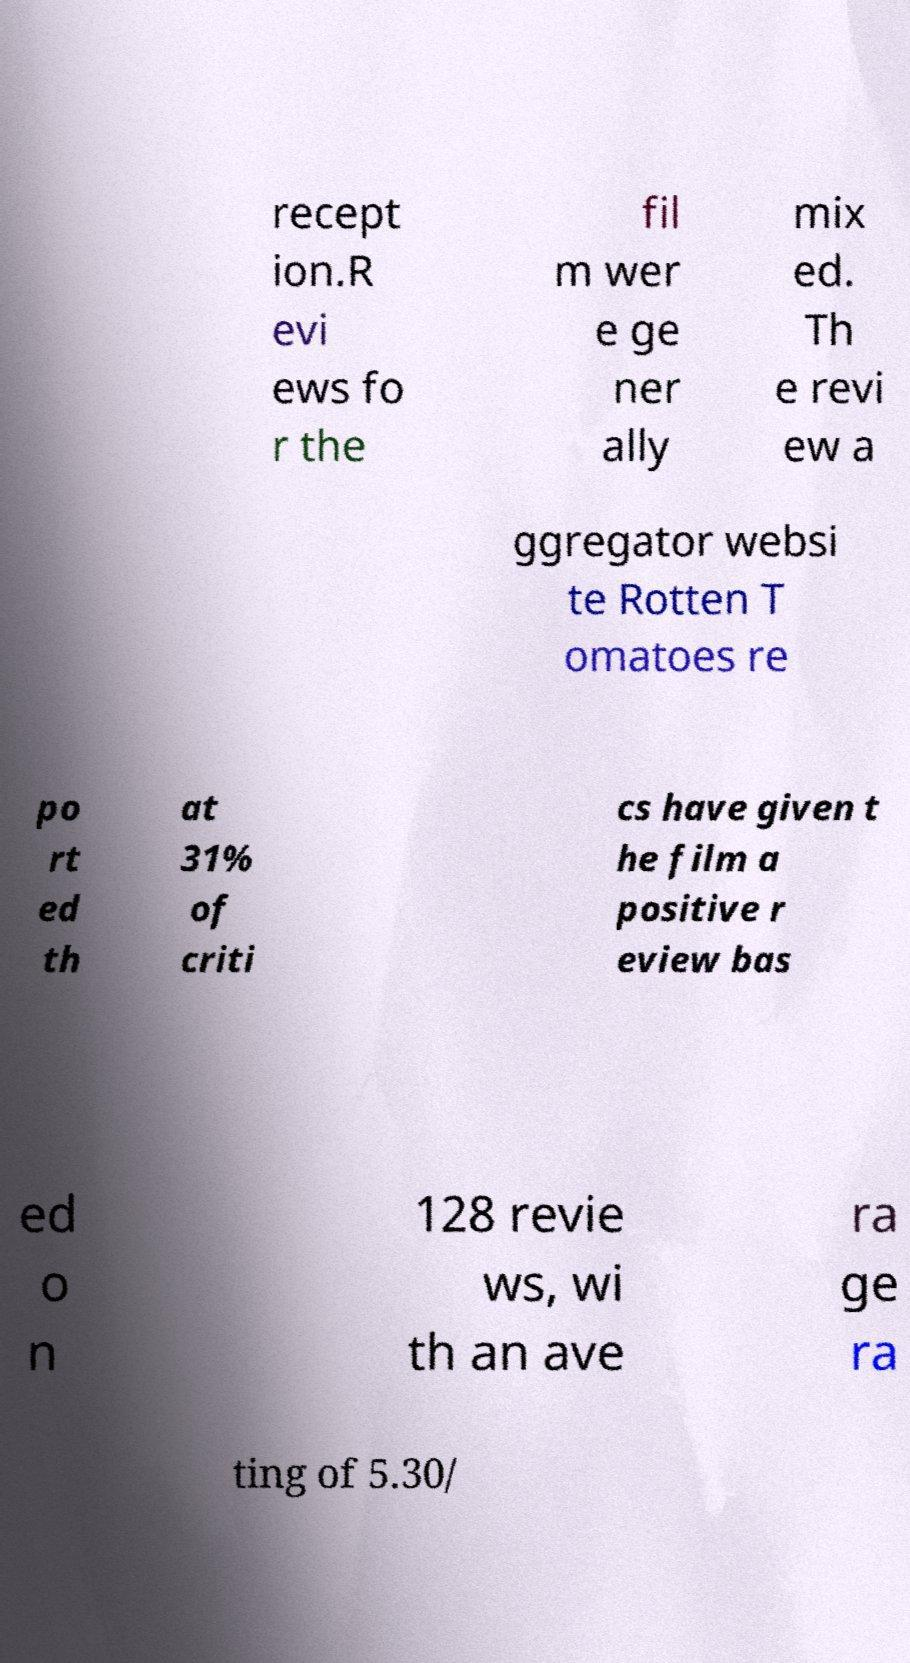Could you assist in decoding the text presented in this image and type it out clearly? recept ion.R evi ews fo r the fil m wer e ge ner ally mix ed. Th e revi ew a ggregator websi te Rotten T omatoes re po rt ed th at 31% of criti cs have given t he film a positive r eview bas ed o n 128 revie ws, wi th an ave ra ge ra ting of 5.30/ 